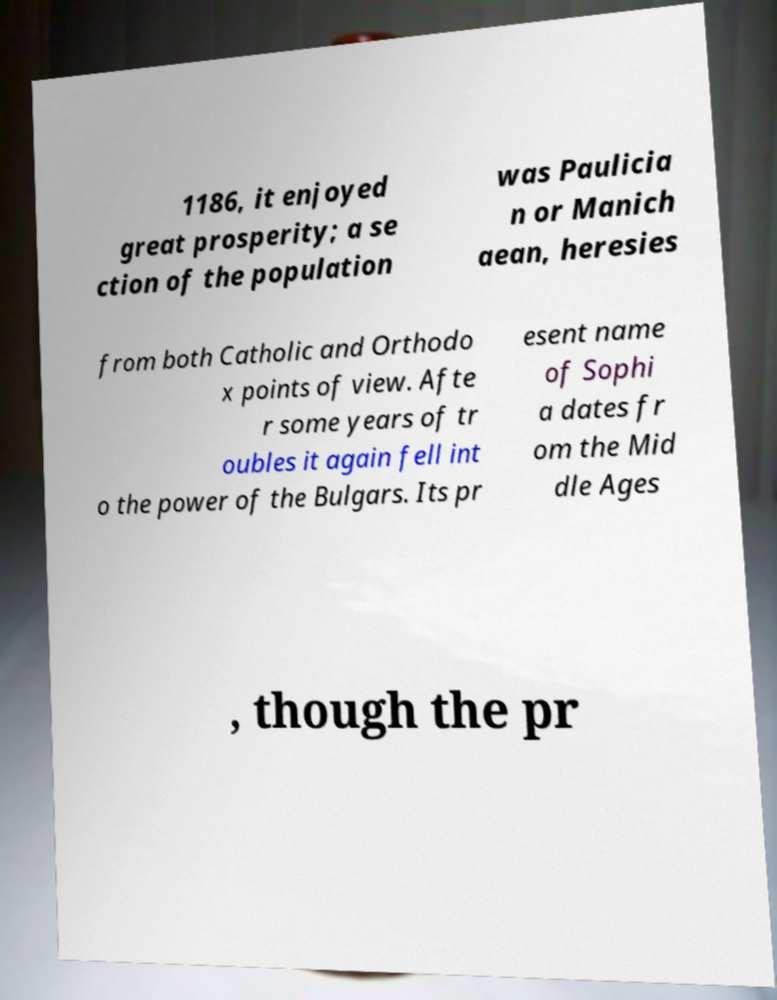What messages or text are displayed in this image? I need them in a readable, typed format. 1186, it enjoyed great prosperity; a se ction of the population was Paulicia n or Manich aean, heresies from both Catholic and Orthodo x points of view. Afte r some years of tr oubles it again fell int o the power of the Bulgars. Its pr esent name of Sophi a dates fr om the Mid dle Ages , though the pr 